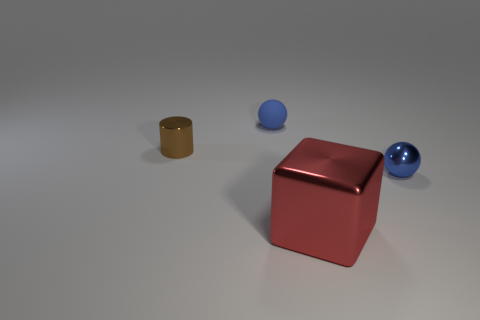Add 4 cubes. How many objects exist? 8 Subtract all brown things. Subtract all large rubber things. How many objects are left? 3 Add 3 big red metal blocks. How many big red metal blocks are left? 4 Add 4 large metallic cubes. How many large metallic cubes exist? 5 Subtract 0 gray blocks. How many objects are left? 4 Subtract all blocks. How many objects are left? 3 